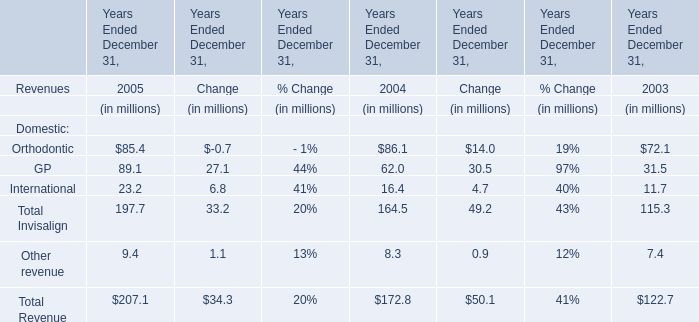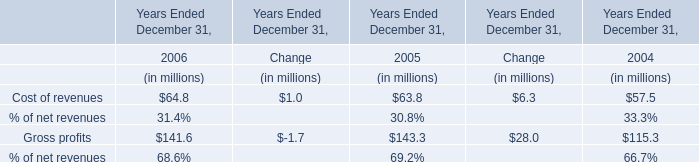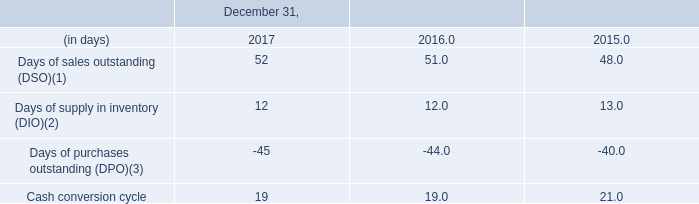In the year with lowest amount of Orthodontic, what's the increasing rate of GP? 
Computations: ((62 - 31.5) / 31.5)
Answer: 0.96825. 